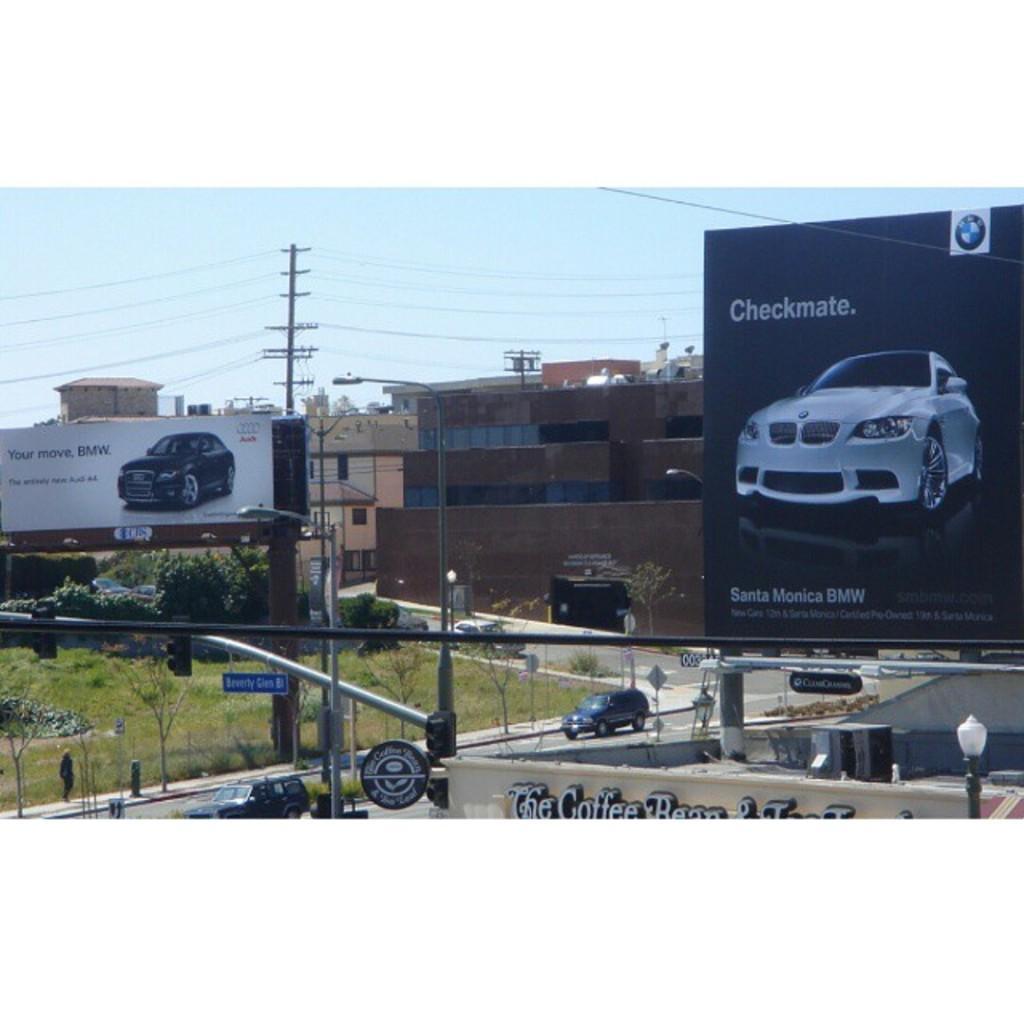Can you describe this image briefly? In this picture we can see vehicles and a person walking on the road, banners, poles, name board, buildings with windows, trees and in the background we can see the sky. 